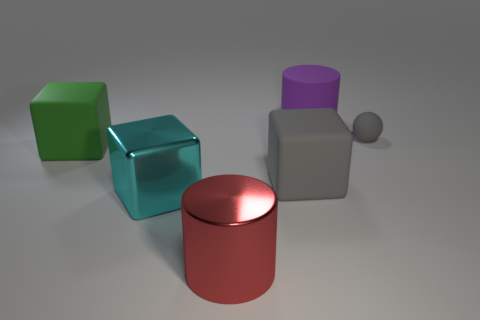Is the number of matte cylinders to the left of the large green block less than the number of balls that are in front of the big red cylinder?
Make the answer very short. No. Are there any other things that are made of the same material as the large gray object?
Offer a terse response. Yes. What shape is the green object that is the same material as the gray block?
Make the answer very short. Cube. Is there anything else that is the same color as the tiny sphere?
Offer a terse response. Yes. What color is the large cylinder in front of the gray rubber object that is to the right of the large gray object?
Provide a short and direct response. Red. What is the large cylinder to the right of the big cylinder in front of the big cylinder behind the tiny gray sphere made of?
Offer a very short reply. Rubber. What number of other spheres are the same size as the gray rubber ball?
Give a very brief answer. 0. There is a block that is on the left side of the large red shiny cylinder and behind the large cyan shiny block; what material is it?
Offer a terse response. Rubber. What number of rubber objects are on the left side of the tiny thing?
Your answer should be very brief. 3. There is a purple matte object; is its shape the same as the gray rubber object that is left of the large purple cylinder?
Offer a terse response. No. 